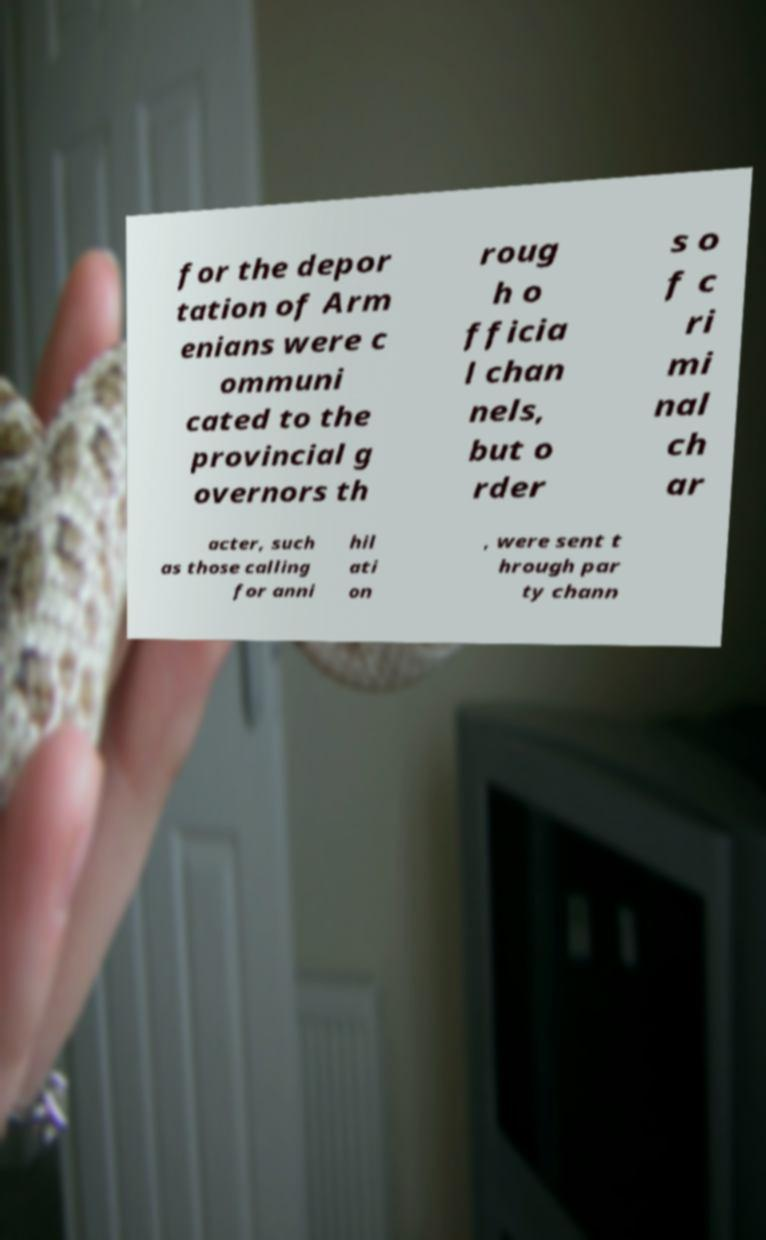Could you assist in decoding the text presented in this image and type it out clearly? for the depor tation of Arm enians were c ommuni cated to the provincial g overnors th roug h o fficia l chan nels, but o rder s o f c ri mi nal ch ar acter, such as those calling for anni hil ati on , were sent t hrough par ty chann 